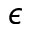Convert formula to latex. <formula><loc_0><loc_0><loc_500><loc_500>\epsilon</formula> 